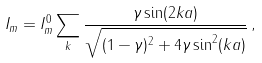Convert formula to latex. <formula><loc_0><loc_0><loc_500><loc_500>I _ { m } = I _ { m } ^ { 0 } \sum _ { k } \frac { \gamma \sin ( 2 k a ) } { \sqrt { ( 1 - \gamma ) ^ { 2 } + 4 \gamma \sin ^ { 2 } ( k a ) } } \, ,</formula> 